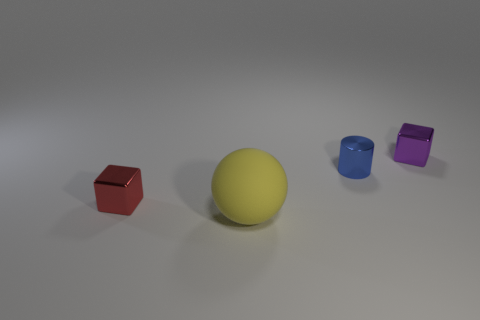What size is the red object that is the same shape as the tiny purple metal object?
Ensure brevity in your answer.  Small. What number of red objects have the same material as the large sphere?
Make the answer very short. 0. There is a small block that is in front of the shiny block behind the tiny shiny cylinder; are there any tiny shiny things that are left of it?
Give a very brief answer. No. The small red thing is what shape?
Your response must be concise. Cube. Is the tiny cube on the right side of the big thing made of the same material as the block that is in front of the cylinder?
Make the answer very short. Yes. What number of small blocks have the same color as the matte thing?
Provide a short and direct response. 0. There is a tiny shiny object that is both in front of the purple block and behind the tiny red metallic object; what is its shape?
Your answer should be very brief. Cylinder. The shiny object that is both in front of the purple block and to the right of the big matte thing is what color?
Give a very brief answer. Blue. Is the number of metal cylinders behind the small blue cylinder greater than the number of tiny red metal things that are in front of the small red metallic cube?
Offer a terse response. No. There is a thing in front of the red block; what is its color?
Make the answer very short. Yellow. 